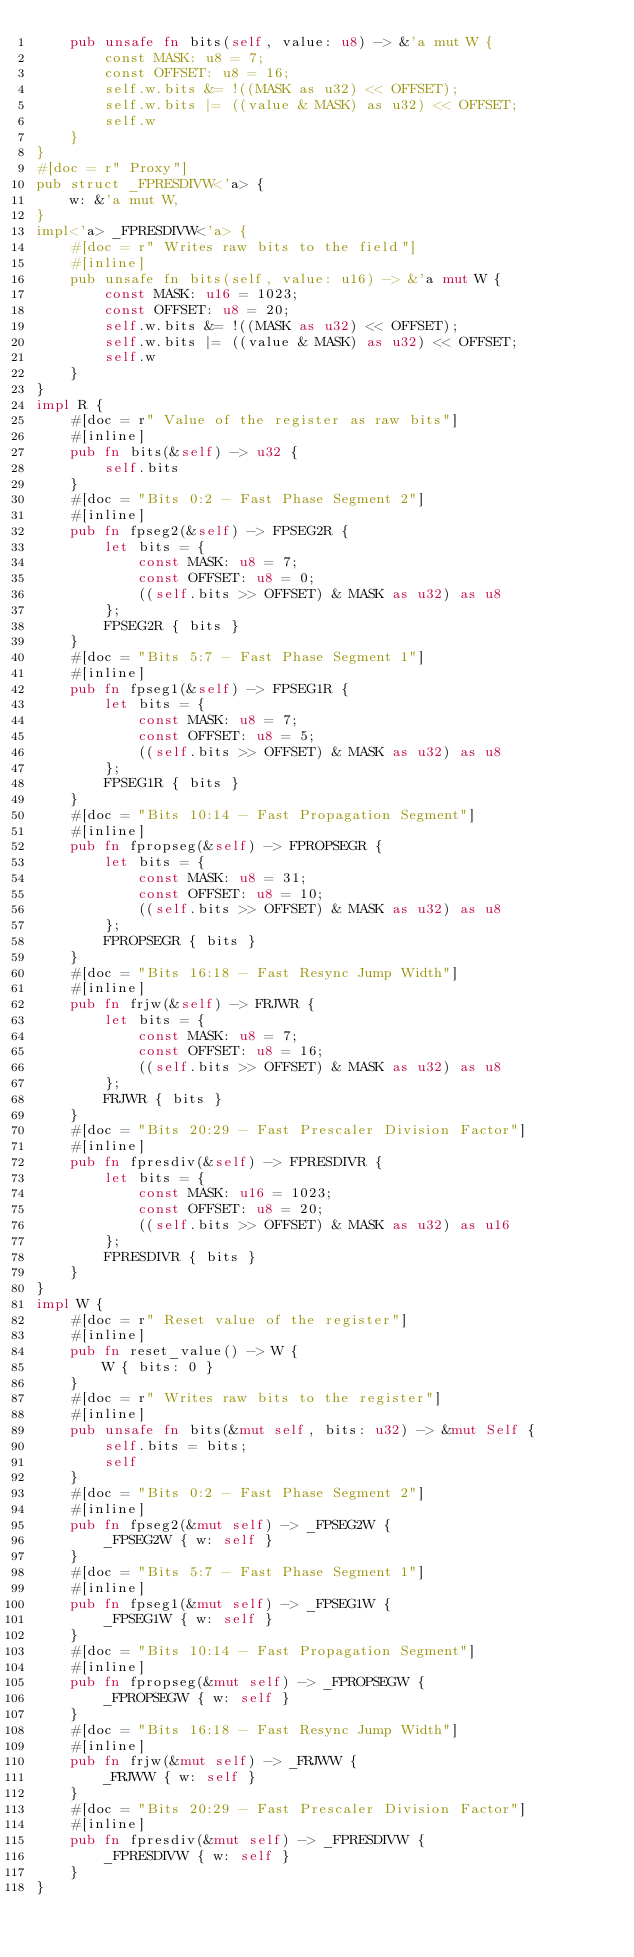Convert code to text. <code><loc_0><loc_0><loc_500><loc_500><_Rust_>    pub unsafe fn bits(self, value: u8) -> &'a mut W {
        const MASK: u8 = 7;
        const OFFSET: u8 = 16;
        self.w.bits &= !((MASK as u32) << OFFSET);
        self.w.bits |= ((value & MASK) as u32) << OFFSET;
        self.w
    }
}
#[doc = r" Proxy"]
pub struct _FPRESDIVW<'a> {
    w: &'a mut W,
}
impl<'a> _FPRESDIVW<'a> {
    #[doc = r" Writes raw bits to the field"]
    #[inline]
    pub unsafe fn bits(self, value: u16) -> &'a mut W {
        const MASK: u16 = 1023;
        const OFFSET: u8 = 20;
        self.w.bits &= !((MASK as u32) << OFFSET);
        self.w.bits |= ((value & MASK) as u32) << OFFSET;
        self.w
    }
}
impl R {
    #[doc = r" Value of the register as raw bits"]
    #[inline]
    pub fn bits(&self) -> u32 {
        self.bits
    }
    #[doc = "Bits 0:2 - Fast Phase Segment 2"]
    #[inline]
    pub fn fpseg2(&self) -> FPSEG2R {
        let bits = {
            const MASK: u8 = 7;
            const OFFSET: u8 = 0;
            ((self.bits >> OFFSET) & MASK as u32) as u8
        };
        FPSEG2R { bits }
    }
    #[doc = "Bits 5:7 - Fast Phase Segment 1"]
    #[inline]
    pub fn fpseg1(&self) -> FPSEG1R {
        let bits = {
            const MASK: u8 = 7;
            const OFFSET: u8 = 5;
            ((self.bits >> OFFSET) & MASK as u32) as u8
        };
        FPSEG1R { bits }
    }
    #[doc = "Bits 10:14 - Fast Propagation Segment"]
    #[inline]
    pub fn fpropseg(&self) -> FPROPSEGR {
        let bits = {
            const MASK: u8 = 31;
            const OFFSET: u8 = 10;
            ((self.bits >> OFFSET) & MASK as u32) as u8
        };
        FPROPSEGR { bits }
    }
    #[doc = "Bits 16:18 - Fast Resync Jump Width"]
    #[inline]
    pub fn frjw(&self) -> FRJWR {
        let bits = {
            const MASK: u8 = 7;
            const OFFSET: u8 = 16;
            ((self.bits >> OFFSET) & MASK as u32) as u8
        };
        FRJWR { bits }
    }
    #[doc = "Bits 20:29 - Fast Prescaler Division Factor"]
    #[inline]
    pub fn fpresdiv(&self) -> FPRESDIVR {
        let bits = {
            const MASK: u16 = 1023;
            const OFFSET: u8 = 20;
            ((self.bits >> OFFSET) & MASK as u32) as u16
        };
        FPRESDIVR { bits }
    }
}
impl W {
    #[doc = r" Reset value of the register"]
    #[inline]
    pub fn reset_value() -> W {
        W { bits: 0 }
    }
    #[doc = r" Writes raw bits to the register"]
    #[inline]
    pub unsafe fn bits(&mut self, bits: u32) -> &mut Self {
        self.bits = bits;
        self
    }
    #[doc = "Bits 0:2 - Fast Phase Segment 2"]
    #[inline]
    pub fn fpseg2(&mut self) -> _FPSEG2W {
        _FPSEG2W { w: self }
    }
    #[doc = "Bits 5:7 - Fast Phase Segment 1"]
    #[inline]
    pub fn fpseg1(&mut self) -> _FPSEG1W {
        _FPSEG1W { w: self }
    }
    #[doc = "Bits 10:14 - Fast Propagation Segment"]
    #[inline]
    pub fn fpropseg(&mut self) -> _FPROPSEGW {
        _FPROPSEGW { w: self }
    }
    #[doc = "Bits 16:18 - Fast Resync Jump Width"]
    #[inline]
    pub fn frjw(&mut self) -> _FRJWW {
        _FRJWW { w: self }
    }
    #[doc = "Bits 20:29 - Fast Prescaler Division Factor"]
    #[inline]
    pub fn fpresdiv(&mut self) -> _FPRESDIVW {
        _FPRESDIVW { w: self }
    }
}
</code> 